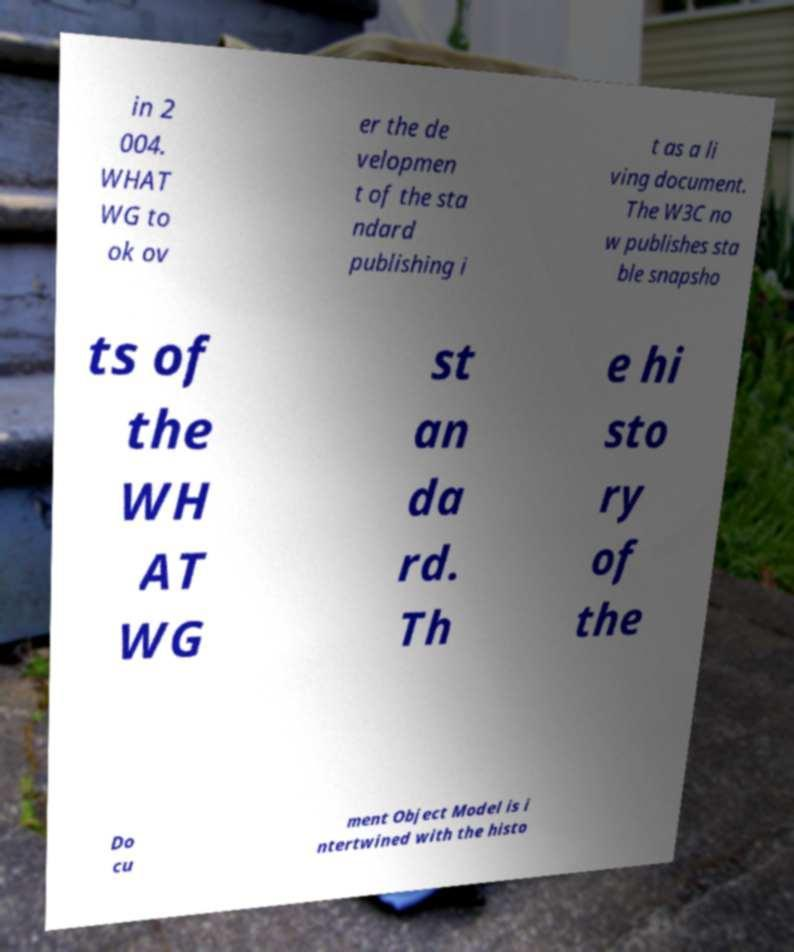Can you accurately transcribe the text from the provided image for me? in 2 004. WHAT WG to ok ov er the de velopmen t of the sta ndard publishing i t as a li ving document. The W3C no w publishes sta ble snapsho ts of the WH AT WG st an da rd. Th e hi sto ry of the Do cu ment Object Model is i ntertwined with the histo 